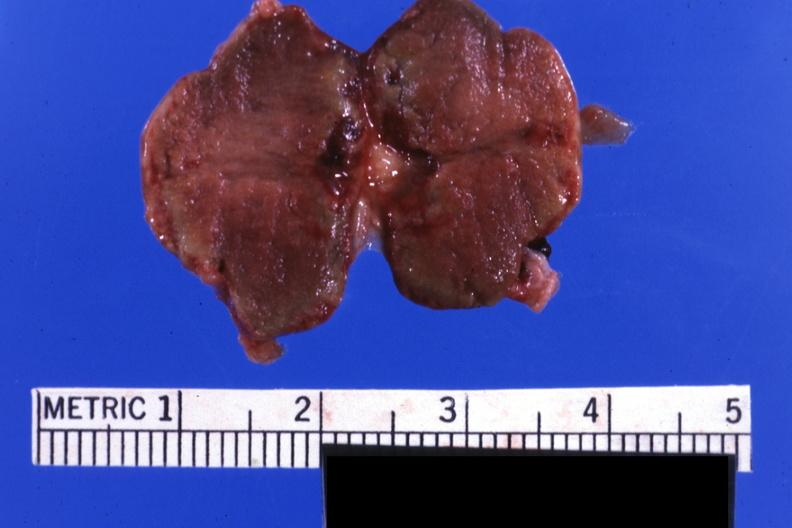s hemorrhage associated with placental abruption present?
Answer the question using a single word or phrase. Yes 